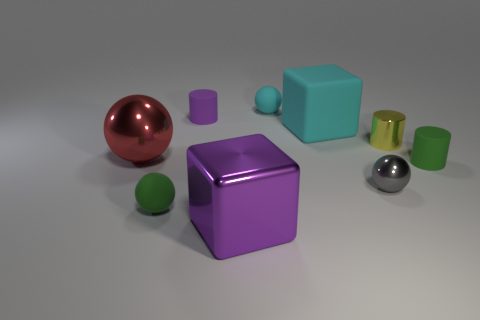What material is the tiny object that is the same color as the matte block?
Provide a short and direct response. Rubber. Is the number of big purple things on the right side of the tiny green cylinder less than the number of tiny green things that are on the right side of the tiny yellow cylinder?
Your response must be concise. Yes. What number of objects are small green rubber spheres or tiny gray spheres in front of the rubber block?
Ensure brevity in your answer.  2. What material is the sphere that is the same size as the purple block?
Give a very brief answer. Metal. Do the small green sphere and the tiny cyan sphere have the same material?
Your answer should be compact. Yes. What color is the sphere that is both behind the tiny green cylinder and on the right side of the big red metal ball?
Your answer should be compact. Cyan. Is the color of the tiny rubber cylinder behind the rubber cube the same as the metal block?
Your response must be concise. Yes. There is a shiny object that is the same size as the purple metal cube; what is its shape?
Your answer should be very brief. Sphere. What number of other objects are there of the same color as the big rubber thing?
Make the answer very short. 1. How many other things are there of the same material as the cyan cube?
Your answer should be compact. 4. 